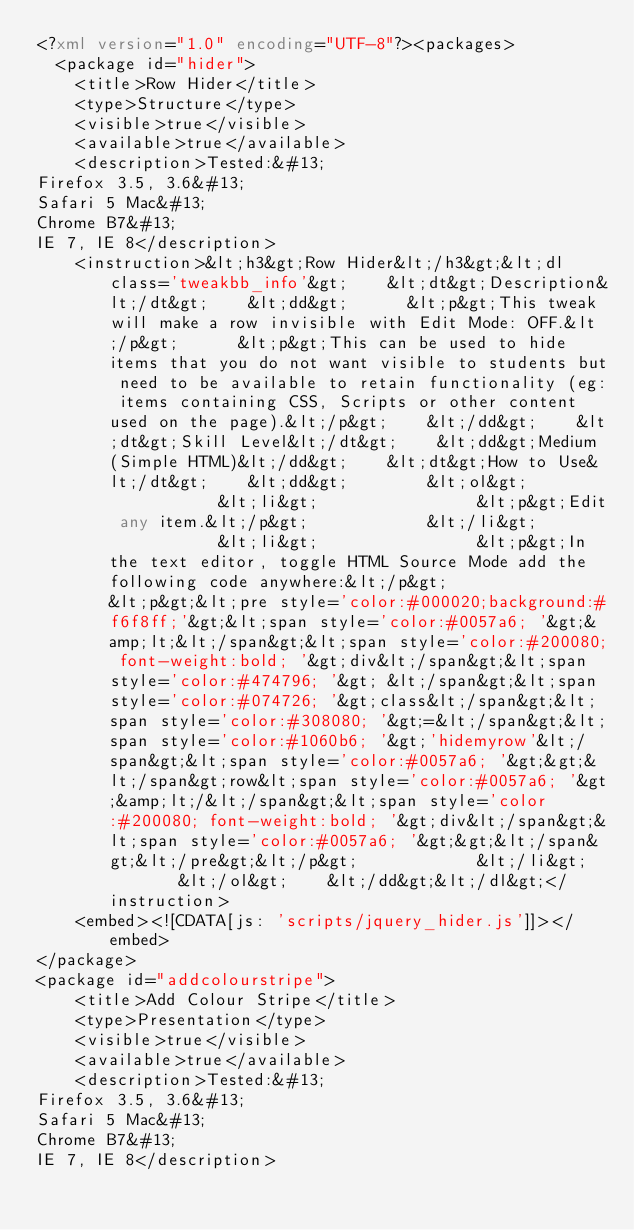Convert code to text. <code><loc_0><loc_0><loc_500><loc_500><_XML_><?xml version="1.0" encoding="UTF-8"?><packages>
	<package id="hider">
		<title>Row Hider</title>
		<type>Structure</type>
		<visible>true</visible>
		<available>true</available>
		<description>Tested:&#13;
Firefox 3.5, 3.6&#13;
Safari 5 Mac&#13;
Chrome B7&#13;
IE 7, IE 8</description>
		<instruction>&lt;h3&gt;Row Hider&lt;/h3&gt;&lt;dl class='tweakbb_info'&gt;    &lt;dt&gt;Description&lt;/dt&gt;    &lt;dd&gt;			&lt;p&gt;This tweak will make a row invisible with Edit Mode: OFF.&lt;/p&gt;			&lt;p&gt;This can be used to hide items that you do not want visible to students but need to be available to retain functionality (eg: items containing CSS, Scripts or other content used on the page).&lt;/p&gt;		&lt;/dd&gt;    &lt;dt&gt;Skill Level&lt;/dt&gt;    &lt;dd&gt;Medium (Simple HTML)&lt;/dd&gt;    &lt;dt&gt;How to Use&lt;/dt&gt;    &lt;dd&gt;        &lt;ol&gt;            &lt;li&gt;                &lt;p&gt;Edit any item.&lt;/p&gt;            &lt;/li&gt;            &lt;li&gt;                &lt;p&gt;In the text editor, toggle HTML Source Mode add the following code anywhere:&lt;/p&gt;                &lt;p&gt;&lt;pre style='color:#000020;background:#f6f8ff;'&gt;&lt;span style='color:#0057a6; '&gt;&amp;lt;&lt;/span&gt;&lt;span style='color:#200080; font-weight:bold; '&gt;div&lt;/span&gt;&lt;span style='color:#474796; '&gt; &lt;/span&gt;&lt;span style='color:#074726; '&gt;class&lt;/span&gt;&lt;span style='color:#308080; '&gt;=&lt;/span&gt;&lt;span style='color:#1060b6; '&gt;'hidemyrow'&lt;/span&gt;&lt;span style='color:#0057a6; '&gt;&gt;&lt;/span&gt;row&lt;span style='color:#0057a6; '&gt;&amp;lt;/&lt;/span&gt;&lt;span style='color:#200080; font-weight:bold; '&gt;div&lt;/span&gt;&lt;span style='color:#0057a6; '&gt;&gt;&lt;/span&gt;&lt;/pre&gt;&lt;/p&gt;            &lt;/li&gt;        &lt;/ol&gt;    &lt;/dd&gt;&lt;/dl&gt;</instruction>
		<embed><![CDATA[js: 'scripts/jquery_hider.js']]></embed>
</package>
<package id="addcolourstripe">
		<title>Add Colour Stripe</title>
		<type>Presentation</type>
		<visible>true</visible>
		<available>true</available>
		<description>Tested:&#13;
Firefox 3.5, 3.6&#13;
Safari 5 Mac&#13;
Chrome B7&#13;
IE 7, IE 8</description></code> 